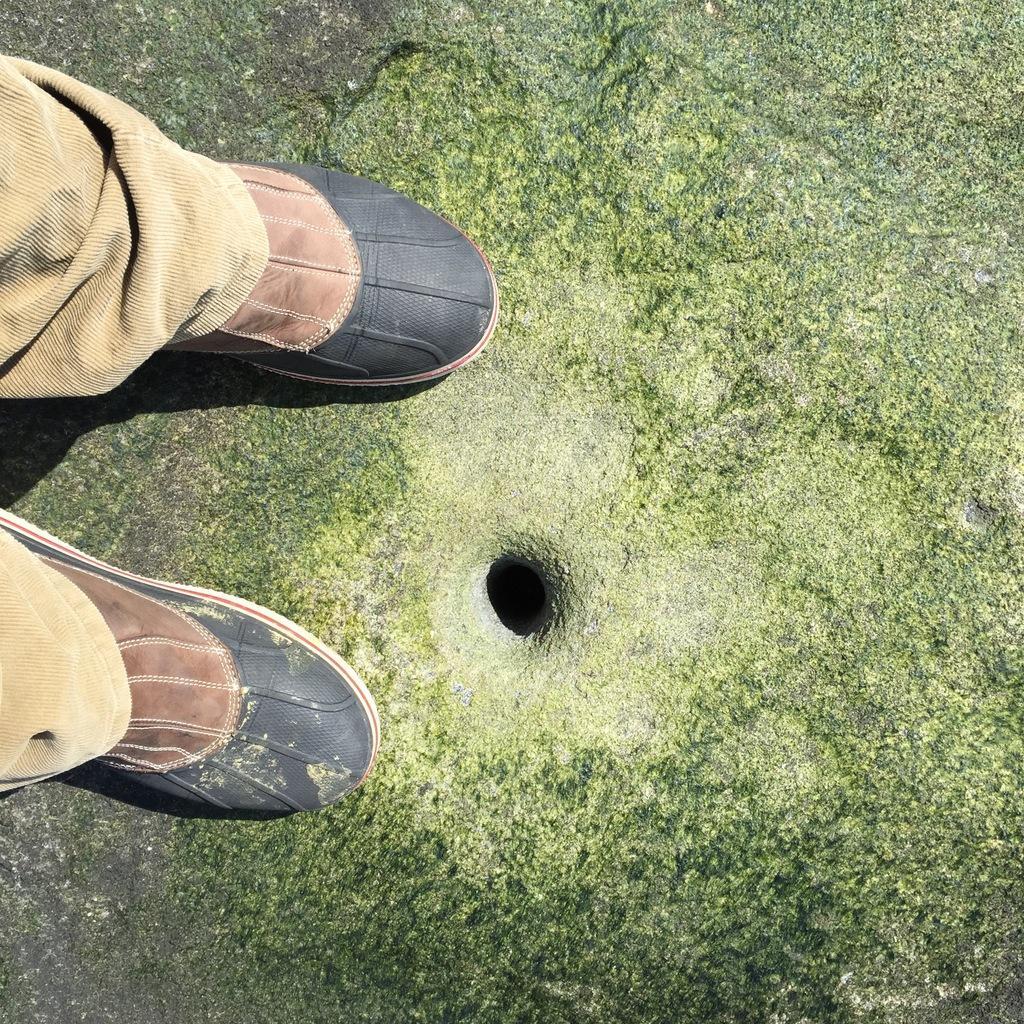How would you summarize this image in a sentence or two? Here we can see legs of a person and there is a hole on the ground. 